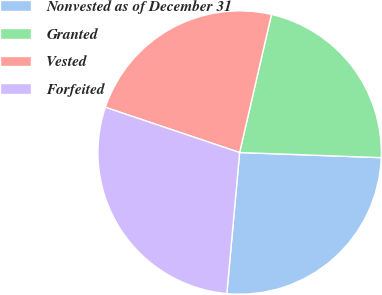Convert chart to OTSL. <chart><loc_0><loc_0><loc_500><loc_500><pie_chart><fcel>Nonvested as of December 31<fcel>Granted<fcel>Vested<fcel>Forfeited<nl><fcel>25.86%<fcel>21.97%<fcel>23.44%<fcel>28.73%<nl></chart> 